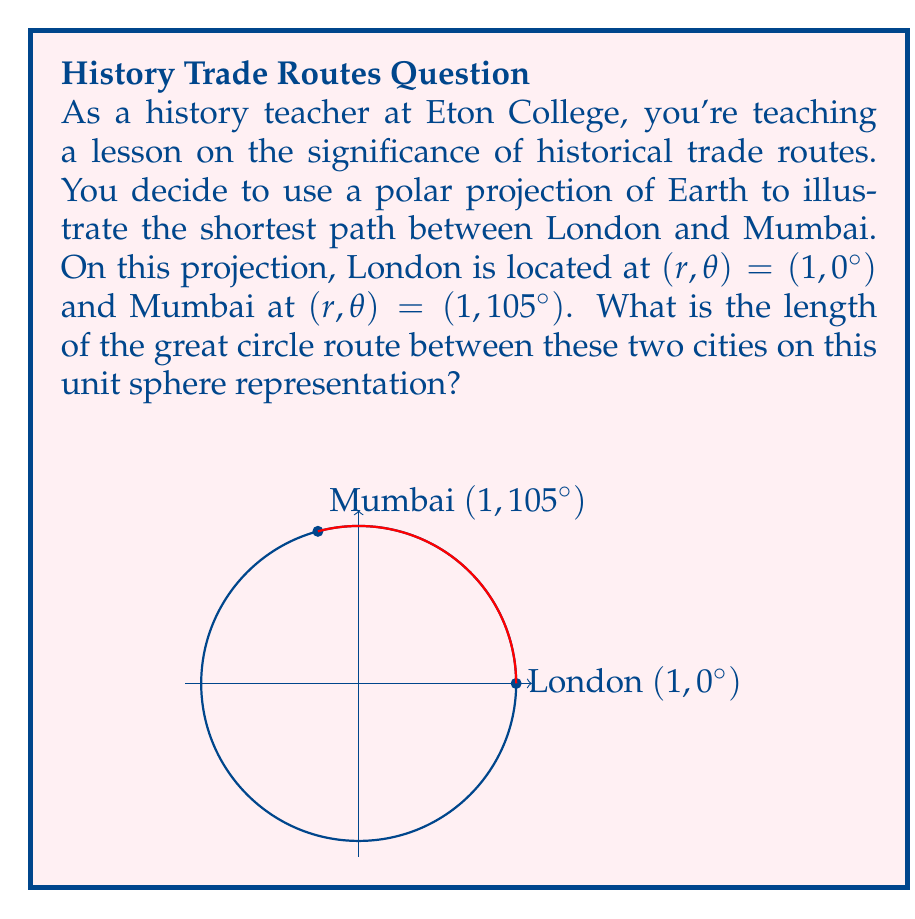Solve this math problem. To solve this problem, we'll use the great circle distance formula on a unit sphere. The steps are as follows:

1) First, recall the formula for the great circle distance $d$ between two points $(r_1, \theta_1)$ and $(r_2, \theta_2)$ on a unit sphere:

   $$d = \arccos(\sin\phi_1 \sin\phi_2 + \cos\phi_1 \cos\phi_2 \cos(\Delta\lambda))$$

   Where $\phi$ is the latitude (90° - $\theta$ in polar coordinates) and $\Delta\lambda$ is the difference in longitude.

2) In our case, both points are on the equator of the polar projection (r = 1), so $\phi_1 = \phi_2 = 0°$. The difference in longitude is $\Delta\lambda = 105° - 0° = 105°$.

3) Substituting these values into the formula:

   $$d = \arccos(\sin 0° \sin 0° + \cos 0° \cos 0° \cos(105°))$$

4) Simplify:
   $$d = \arccos(1 \cdot \cos(105°))$$

5) Calculate $\cos(105°)$:
   $$d = \arccos(-0.2588)$$

6) Finally, calculate the arccosine:
   $$d \approx 1.8326 \text{ radians}$$

This is the shortest distance between London and Mumbai on the surface of this unit sphere representation.
Answer: $1.8326$ radians 